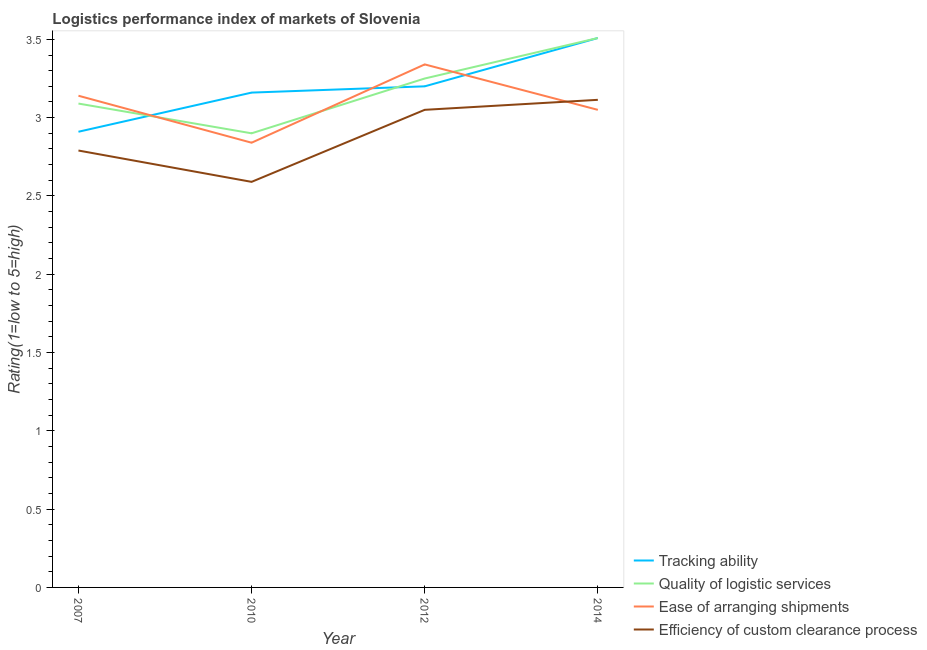How many different coloured lines are there?
Provide a short and direct response. 4. Does the line corresponding to lpi rating of tracking ability intersect with the line corresponding to lpi rating of ease of arranging shipments?
Offer a very short reply. Yes. What is the lpi rating of tracking ability in 2007?
Provide a short and direct response. 2.91. Across all years, what is the maximum lpi rating of tracking ability?
Ensure brevity in your answer.  3.51. Across all years, what is the minimum lpi rating of ease of arranging shipments?
Your answer should be compact. 2.84. What is the total lpi rating of ease of arranging shipments in the graph?
Offer a very short reply. 12.37. What is the difference between the lpi rating of tracking ability in 2012 and that in 2014?
Offer a very short reply. -0.31. What is the difference between the lpi rating of efficiency of custom clearance process in 2012 and the lpi rating of tracking ability in 2007?
Offer a very short reply. 0.14. What is the average lpi rating of tracking ability per year?
Offer a very short reply. 3.19. In the year 2010, what is the difference between the lpi rating of quality of logistic services and lpi rating of ease of arranging shipments?
Provide a short and direct response. 0.06. In how many years, is the lpi rating of ease of arranging shipments greater than 1.1?
Give a very brief answer. 4. What is the ratio of the lpi rating of tracking ability in 2010 to that in 2014?
Make the answer very short. 0.9. Is the lpi rating of efficiency of custom clearance process in 2010 less than that in 2012?
Offer a very short reply. Yes. What is the difference between the highest and the second highest lpi rating of quality of logistic services?
Provide a short and direct response. 0.26. What is the difference between the highest and the lowest lpi rating of quality of logistic services?
Keep it short and to the point. 0.61. In how many years, is the lpi rating of efficiency of custom clearance process greater than the average lpi rating of efficiency of custom clearance process taken over all years?
Give a very brief answer. 2. Is the lpi rating of ease of arranging shipments strictly greater than the lpi rating of efficiency of custom clearance process over the years?
Your answer should be very brief. No. How many lines are there?
Give a very brief answer. 4. What is the difference between two consecutive major ticks on the Y-axis?
Your response must be concise. 0.5. Does the graph contain any zero values?
Your response must be concise. No. How many legend labels are there?
Your answer should be very brief. 4. What is the title of the graph?
Give a very brief answer. Logistics performance index of markets of Slovenia. Does "Switzerland" appear as one of the legend labels in the graph?
Offer a very short reply. No. What is the label or title of the Y-axis?
Offer a very short reply. Rating(1=low to 5=high). What is the Rating(1=low to 5=high) in Tracking ability in 2007?
Your answer should be very brief. 2.91. What is the Rating(1=low to 5=high) in Quality of logistic services in 2007?
Provide a succinct answer. 3.09. What is the Rating(1=low to 5=high) in Ease of arranging shipments in 2007?
Keep it short and to the point. 3.14. What is the Rating(1=low to 5=high) in Efficiency of custom clearance process in 2007?
Offer a terse response. 2.79. What is the Rating(1=low to 5=high) in Tracking ability in 2010?
Provide a succinct answer. 3.16. What is the Rating(1=low to 5=high) in Quality of logistic services in 2010?
Provide a succinct answer. 2.9. What is the Rating(1=low to 5=high) in Ease of arranging shipments in 2010?
Provide a short and direct response. 2.84. What is the Rating(1=low to 5=high) of Efficiency of custom clearance process in 2010?
Offer a very short reply. 2.59. What is the Rating(1=low to 5=high) of Ease of arranging shipments in 2012?
Your response must be concise. 3.34. What is the Rating(1=low to 5=high) in Efficiency of custom clearance process in 2012?
Your answer should be very brief. 3.05. What is the Rating(1=low to 5=high) in Tracking ability in 2014?
Provide a short and direct response. 3.51. What is the Rating(1=low to 5=high) in Quality of logistic services in 2014?
Give a very brief answer. 3.51. What is the Rating(1=low to 5=high) of Ease of arranging shipments in 2014?
Make the answer very short. 3.05. What is the Rating(1=low to 5=high) of Efficiency of custom clearance process in 2014?
Offer a terse response. 3.11. Across all years, what is the maximum Rating(1=low to 5=high) of Tracking ability?
Offer a very short reply. 3.51. Across all years, what is the maximum Rating(1=low to 5=high) of Quality of logistic services?
Give a very brief answer. 3.51. Across all years, what is the maximum Rating(1=low to 5=high) in Ease of arranging shipments?
Give a very brief answer. 3.34. Across all years, what is the maximum Rating(1=low to 5=high) of Efficiency of custom clearance process?
Offer a very short reply. 3.11. Across all years, what is the minimum Rating(1=low to 5=high) in Tracking ability?
Provide a short and direct response. 2.91. Across all years, what is the minimum Rating(1=low to 5=high) in Ease of arranging shipments?
Ensure brevity in your answer.  2.84. Across all years, what is the minimum Rating(1=low to 5=high) in Efficiency of custom clearance process?
Give a very brief answer. 2.59. What is the total Rating(1=low to 5=high) of Tracking ability in the graph?
Make the answer very short. 12.78. What is the total Rating(1=low to 5=high) in Quality of logistic services in the graph?
Your answer should be compact. 12.75. What is the total Rating(1=low to 5=high) in Ease of arranging shipments in the graph?
Keep it short and to the point. 12.37. What is the total Rating(1=low to 5=high) of Efficiency of custom clearance process in the graph?
Give a very brief answer. 11.54. What is the difference between the Rating(1=low to 5=high) in Quality of logistic services in 2007 and that in 2010?
Offer a very short reply. 0.19. What is the difference between the Rating(1=low to 5=high) in Tracking ability in 2007 and that in 2012?
Your answer should be very brief. -0.29. What is the difference between the Rating(1=low to 5=high) of Quality of logistic services in 2007 and that in 2012?
Keep it short and to the point. -0.16. What is the difference between the Rating(1=low to 5=high) in Ease of arranging shipments in 2007 and that in 2012?
Make the answer very short. -0.2. What is the difference between the Rating(1=low to 5=high) in Efficiency of custom clearance process in 2007 and that in 2012?
Your response must be concise. -0.26. What is the difference between the Rating(1=low to 5=high) in Tracking ability in 2007 and that in 2014?
Make the answer very short. -0.6. What is the difference between the Rating(1=low to 5=high) in Quality of logistic services in 2007 and that in 2014?
Your answer should be very brief. -0.42. What is the difference between the Rating(1=low to 5=high) in Ease of arranging shipments in 2007 and that in 2014?
Make the answer very short. 0.09. What is the difference between the Rating(1=low to 5=high) in Efficiency of custom clearance process in 2007 and that in 2014?
Make the answer very short. -0.32. What is the difference between the Rating(1=low to 5=high) in Tracking ability in 2010 and that in 2012?
Keep it short and to the point. -0.04. What is the difference between the Rating(1=low to 5=high) in Quality of logistic services in 2010 and that in 2012?
Your answer should be compact. -0.35. What is the difference between the Rating(1=low to 5=high) in Efficiency of custom clearance process in 2010 and that in 2012?
Offer a terse response. -0.46. What is the difference between the Rating(1=low to 5=high) of Tracking ability in 2010 and that in 2014?
Your answer should be very brief. -0.35. What is the difference between the Rating(1=low to 5=high) of Quality of logistic services in 2010 and that in 2014?
Your response must be concise. -0.61. What is the difference between the Rating(1=low to 5=high) of Ease of arranging shipments in 2010 and that in 2014?
Provide a succinct answer. -0.21. What is the difference between the Rating(1=low to 5=high) of Efficiency of custom clearance process in 2010 and that in 2014?
Your answer should be compact. -0.52. What is the difference between the Rating(1=low to 5=high) of Tracking ability in 2012 and that in 2014?
Offer a very short reply. -0.31. What is the difference between the Rating(1=low to 5=high) of Quality of logistic services in 2012 and that in 2014?
Ensure brevity in your answer.  -0.26. What is the difference between the Rating(1=low to 5=high) of Ease of arranging shipments in 2012 and that in 2014?
Provide a short and direct response. 0.29. What is the difference between the Rating(1=low to 5=high) of Efficiency of custom clearance process in 2012 and that in 2014?
Make the answer very short. -0.06. What is the difference between the Rating(1=low to 5=high) in Tracking ability in 2007 and the Rating(1=low to 5=high) in Quality of logistic services in 2010?
Offer a terse response. 0.01. What is the difference between the Rating(1=low to 5=high) of Tracking ability in 2007 and the Rating(1=low to 5=high) of Ease of arranging shipments in 2010?
Your answer should be compact. 0.07. What is the difference between the Rating(1=low to 5=high) of Tracking ability in 2007 and the Rating(1=low to 5=high) of Efficiency of custom clearance process in 2010?
Offer a terse response. 0.32. What is the difference between the Rating(1=low to 5=high) in Quality of logistic services in 2007 and the Rating(1=low to 5=high) in Ease of arranging shipments in 2010?
Your answer should be very brief. 0.25. What is the difference between the Rating(1=low to 5=high) in Quality of logistic services in 2007 and the Rating(1=low to 5=high) in Efficiency of custom clearance process in 2010?
Ensure brevity in your answer.  0.5. What is the difference between the Rating(1=low to 5=high) of Ease of arranging shipments in 2007 and the Rating(1=low to 5=high) of Efficiency of custom clearance process in 2010?
Provide a short and direct response. 0.55. What is the difference between the Rating(1=low to 5=high) of Tracking ability in 2007 and the Rating(1=low to 5=high) of Quality of logistic services in 2012?
Offer a very short reply. -0.34. What is the difference between the Rating(1=low to 5=high) in Tracking ability in 2007 and the Rating(1=low to 5=high) in Ease of arranging shipments in 2012?
Your answer should be compact. -0.43. What is the difference between the Rating(1=low to 5=high) of Tracking ability in 2007 and the Rating(1=low to 5=high) of Efficiency of custom clearance process in 2012?
Your response must be concise. -0.14. What is the difference between the Rating(1=low to 5=high) of Quality of logistic services in 2007 and the Rating(1=low to 5=high) of Ease of arranging shipments in 2012?
Offer a terse response. -0.25. What is the difference between the Rating(1=low to 5=high) of Ease of arranging shipments in 2007 and the Rating(1=low to 5=high) of Efficiency of custom clearance process in 2012?
Provide a succinct answer. 0.09. What is the difference between the Rating(1=low to 5=high) in Tracking ability in 2007 and the Rating(1=low to 5=high) in Quality of logistic services in 2014?
Offer a terse response. -0.6. What is the difference between the Rating(1=low to 5=high) in Tracking ability in 2007 and the Rating(1=low to 5=high) in Ease of arranging shipments in 2014?
Offer a terse response. -0.14. What is the difference between the Rating(1=low to 5=high) in Tracking ability in 2007 and the Rating(1=low to 5=high) in Efficiency of custom clearance process in 2014?
Your answer should be compact. -0.2. What is the difference between the Rating(1=low to 5=high) of Quality of logistic services in 2007 and the Rating(1=low to 5=high) of Ease of arranging shipments in 2014?
Make the answer very short. 0.04. What is the difference between the Rating(1=low to 5=high) in Quality of logistic services in 2007 and the Rating(1=low to 5=high) in Efficiency of custom clearance process in 2014?
Provide a succinct answer. -0.02. What is the difference between the Rating(1=low to 5=high) of Ease of arranging shipments in 2007 and the Rating(1=low to 5=high) of Efficiency of custom clearance process in 2014?
Your answer should be very brief. 0.03. What is the difference between the Rating(1=low to 5=high) in Tracking ability in 2010 and the Rating(1=low to 5=high) in Quality of logistic services in 2012?
Give a very brief answer. -0.09. What is the difference between the Rating(1=low to 5=high) of Tracking ability in 2010 and the Rating(1=low to 5=high) of Ease of arranging shipments in 2012?
Provide a short and direct response. -0.18. What is the difference between the Rating(1=low to 5=high) in Tracking ability in 2010 and the Rating(1=low to 5=high) in Efficiency of custom clearance process in 2012?
Ensure brevity in your answer.  0.11. What is the difference between the Rating(1=low to 5=high) in Quality of logistic services in 2010 and the Rating(1=low to 5=high) in Ease of arranging shipments in 2012?
Give a very brief answer. -0.44. What is the difference between the Rating(1=low to 5=high) of Quality of logistic services in 2010 and the Rating(1=low to 5=high) of Efficiency of custom clearance process in 2012?
Make the answer very short. -0.15. What is the difference between the Rating(1=low to 5=high) in Ease of arranging shipments in 2010 and the Rating(1=low to 5=high) in Efficiency of custom clearance process in 2012?
Your response must be concise. -0.21. What is the difference between the Rating(1=low to 5=high) in Tracking ability in 2010 and the Rating(1=low to 5=high) in Quality of logistic services in 2014?
Provide a short and direct response. -0.35. What is the difference between the Rating(1=low to 5=high) in Tracking ability in 2010 and the Rating(1=low to 5=high) in Ease of arranging shipments in 2014?
Keep it short and to the point. 0.11. What is the difference between the Rating(1=low to 5=high) in Tracking ability in 2010 and the Rating(1=low to 5=high) in Efficiency of custom clearance process in 2014?
Keep it short and to the point. 0.05. What is the difference between the Rating(1=low to 5=high) of Quality of logistic services in 2010 and the Rating(1=low to 5=high) of Ease of arranging shipments in 2014?
Your response must be concise. -0.15. What is the difference between the Rating(1=low to 5=high) of Quality of logistic services in 2010 and the Rating(1=low to 5=high) of Efficiency of custom clearance process in 2014?
Provide a short and direct response. -0.21. What is the difference between the Rating(1=low to 5=high) of Ease of arranging shipments in 2010 and the Rating(1=low to 5=high) of Efficiency of custom clearance process in 2014?
Your answer should be very brief. -0.27. What is the difference between the Rating(1=low to 5=high) in Tracking ability in 2012 and the Rating(1=low to 5=high) in Quality of logistic services in 2014?
Your response must be concise. -0.31. What is the difference between the Rating(1=low to 5=high) of Tracking ability in 2012 and the Rating(1=low to 5=high) of Ease of arranging shipments in 2014?
Offer a terse response. 0.15. What is the difference between the Rating(1=low to 5=high) in Tracking ability in 2012 and the Rating(1=low to 5=high) in Efficiency of custom clearance process in 2014?
Your response must be concise. 0.09. What is the difference between the Rating(1=low to 5=high) in Quality of logistic services in 2012 and the Rating(1=low to 5=high) in Ease of arranging shipments in 2014?
Provide a short and direct response. 0.2. What is the difference between the Rating(1=low to 5=high) in Quality of logistic services in 2012 and the Rating(1=low to 5=high) in Efficiency of custom clearance process in 2014?
Make the answer very short. 0.14. What is the difference between the Rating(1=low to 5=high) of Ease of arranging shipments in 2012 and the Rating(1=low to 5=high) of Efficiency of custom clearance process in 2014?
Give a very brief answer. 0.23. What is the average Rating(1=low to 5=high) of Tracking ability per year?
Offer a terse response. 3.19. What is the average Rating(1=low to 5=high) of Quality of logistic services per year?
Your response must be concise. 3.19. What is the average Rating(1=low to 5=high) in Ease of arranging shipments per year?
Offer a very short reply. 3.09. What is the average Rating(1=low to 5=high) in Efficiency of custom clearance process per year?
Offer a very short reply. 2.89. In the year 2007, what is the difference between the Rating(1=low to 5=high) in Tracking ability and Rating(1=low to 5=high) in Quality of logistic services?
Offer a very short reply. -0.18. In the year 2007, what is the difference between the Rating(1=low to 5=high) of Tracking ability and Rating(1=low to 5=high) of Ease of arranging shipments?
Your answer should be very brief. -0.23. In the year 2007, what is the difference between the Rating(1=low to 5=high) of Tracking ability and Rating(1=low to 5=high) of Efficiency of custom clearance process?
Offer a terse response. 0.12. In the year 2007, what is the difference between the Rating(1=low to 5=high) in Quality of logistic services and Rating(1=low to 5=high) in Ease of arranging shipments?
Offer a terse response. -0.05. In the year 2010, what is the difference between the Rating(1=low to 5=high) in Tracking ability and Rating(1=low to 5=high) in Quality of logistic services?
Keep it short and to the point. 0.26. In the year 2010, what is the difference between the Rating(1=low to 5=high) of Tracking ability and Rating(1=low to 5=high) of Ease of arranging shipments?
Your answer should be very brief. 0.32. In the year 2010, what is the difference between the Rating(1=low to 5=high) of Tracking ability and Rating(1=low to 5=high) of Efficiency of custom clearance process?
Your answer should be very brief. 0.57. In the year 2010, what is the difference between the Rating(1=low to 5=high) in Quality of logistic services and Rating(1=low to 5=high) in Efficiency of custom clearance process?
Your answer should be very brief. 0.31. In the year 2010, what is the difference between the Rating(1=low to 5=high) of Ease of arranging shipments and Rating(1=low to 5=high) of Efficiency of custom clearance process?
Your response must be concise. 0.25. In the year 2012, what is the difference between the Rating(1=low to 5=high) of Tracking ability and Rating(1=low to 5=high) of Ease of arranging shipments?
Offer a terse response. -0.14. In the year 2012, what is the difference between the Rating(1=low to 5=high) in Quality of logistic services and Rating(1=low to 5=high) in Ease of arranging shipments?
Your answer should be compact. -0.09. In the year 2012, what is the difference between the Rating(1=low to 5=high) of Ease of arranging shipments and Rating(1=low to 5=high) of Efficiency of custom clearance process?
Make the answer very short. 0.29. In the year 2014, what is the difference between the Rating(1=low to 5=high) of Tracking ability and Rating(1=low to 5=high) of Ease of arranging shipments?
Provide a short and direct response. 0.46. In the year 2014, what is the difference between the Rating(1=low to 5=high) of Tracking ability and Rating(1=low to 5=high) of Efficiency of custom clearance process?
Your answer should be compact. 0.39. In the year 2014, what is the difference between the Rating(1=low to 5=high) in Quality of logistic services and Rating(1=low to 5=high) in Ease of arranging shipments?
Your answer should be very brief. 0.46. In the year 2014, what is the difference between the Rating(1=low to 5=high) in Quality of logistic services and Rating(1=low to 5=high) in Efficiency of custom clearance process?
Provide a short and direct response. 0.39. In the year 2014, what is the difference between the Rating(1=low to 5=high) in Ease of arranging shipments and Rating(1=low to 5=high) in Efficiency of custom clearance process?
Make the answer very short. -0.06. What is the ratio of the Rating(1=low to 5=high) in Tracking ability in 2007 to that in 2010?
Your answer should be compact. 0.92. What is the ratio of the Rating(1=low to 5=high) of Quality of logistic services in 2007 to that in 2010?
Give a very brief answer. 1.07. What is the ratio of the Rating(1=low to 5=high) in Ease of arranging shipments in 2007 to that in 2010?
Make the answer very short. 1.11. What is the ratio of the Rating(1=low to 5=high) in Efficiency of custom clearance process in 2007 to that in 2010?
Make the answer very short. 1.08. What is the ratio of the Rating(1=low to 5=high) in Tracking ability in 2007 to that in 2012?
Make the answer very short. 0.91. What is the ratio of the Rating(1=low to 5=high) in Quality of logistic services in 2007 to that in 2012?
Keep it short and to the point. 0.95. What is the ratio of the Rating(1=low to 5=high) of Ease of arranging shipments in 2007 to that in 2012?
Ensure brevity in your answer.  0.94. What is the ratio of the Rating(1=low to 5=high) in Efficiency of custom clearance process in 2007 to that in 2012?
Your answer should be very brief. 0.91. What is the ratio of the Rating(1=low to 5=high) of Tracking ability in 2007 to that in 2014?
Ensure brevity in your answer.  0.83. What is the ratio of the Rating(1=low to 5=high) of Quality of logistic services in 2007 to that in 2014?
Keep it short and to the point. 0.88. What is the ratio of the Rating(1=low to 5=high) of Ease of arranging shipments in 2007 to that in 2014?
Your answer should be compact. 1.03. What is the ratio of the Rating(1=low to 5=high) in Efficiency of custom clearance process in 2007 to that in 2014?
Your answer should be compact. 0.9. What is the ratio of the Rating(1=low to 5=high) in Tracking ability in 2010 to that in 2012?
Make the answer very short. 0.99. What is the ratio of the Rating(1=low to 5=high) of Quality of logistic services in 2010 to that in 2012?
Provide a short and direct response. 0.89. What is the ratio of the Rating(1=low to 5=high) of Ease of arranging shipments in 2010 to that in 2012?
Give a very brief answer. 0.85. What is the ratio of the Rating(1=low to 5=high) in Efficiency of custom clearance process in 2010 to that in 2012?
Offer a terse response. 0.85. What is the ratio of the Rating(1=low to 5=high) in Tracking ability in 2010 to that in 2014?
Give a very brief answer. 0.9. What is the ratio of the Rating(1=low to 5=high) of Quality of logistic services in 2010 to that in 2014?
Offer a very short reply. 0.83. What is the ratio of the Rating(1=low to 5=high) in Ease of arranging shipments in 2010 to that in 2014?
Make the answer very short. 0.93. What is the ratio of the Rating(1=low to 5=high) in Efficiency of custom clearance process in 2010 to that in 2014?
Your answer should be very brief. 0.83. What is the ratio of the Rating(1=low to 5=high) in Tracking ability in 2012 to that in 2014?
Give a very brief answer. 0.91. What is the ratio of the Rating(1=low to 5=high) in Quality of logistic services in 2012 to that in 2014?
Give a very brief answer. 0.93. What is the ratio of the Rating(1=low to 5=high) in Ease of arranging shipments in 2012 to that in 2014?
Your answer should be compact. 1.1. What is the ratio of the Rating(1=low to 5=high) in Efficiency of custom clearance process in 2012 to that in 2014?
Make the answer very short. 0.98. What is the difference between the highest and the second highest Rating(1=low to 5=high) in Tracking ability?
Ensure brevity in your answer.  0.31. What is the difference between the highest and the second highest Rating(1=low to 5=high) in Quality of logistic services?
Provide a short and direct response. 0.26. What is the difference between the highest and the second highest Rating(1=low to 5=high) of Ease of arranging shipments?
Make the answer very short. 0.2. What is the difference between the highest and the second highest Rating(1=low to 5=high) of Efficiency of custom clearance process?
Provide a succinct answer. 0.06. What is the difference between the highest and the lowest Rating(1=low to 5=high) in Tracking ability?
Your answer should be compact. 0.6. What is the difference between the highest and the lowest Rating(1=low to 5=high) in Quality of logistic services?
Offer a very short reply. 0.61. What is the difference between the highest and the lowest Rating(1=low to 5=high) of Efficiency of custom clearance process?
Provide a short and direct response. 0.52. 